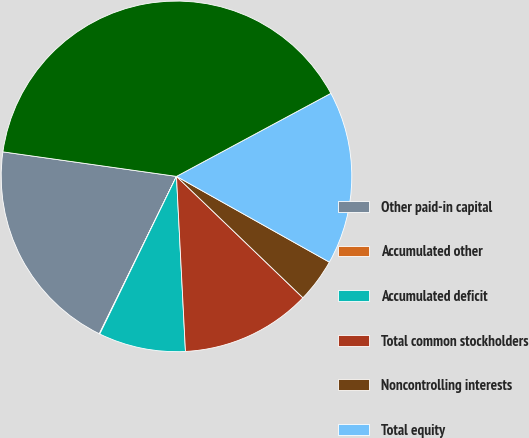Convert chart to OTSL. <chart><loc_0><loc_0><loc_500><loc_500><pie_chart><fcel>Other paid-in capital<fcel>Accumulated other<fcel>Accumulated deficit<fcel>Total common stockholders<fcel>Noncontrolling interests<fcel>Total equity<fcel>Total Liabilities and Equity<nl><fcel>19.98%<fcel>0.05%<fcel>8.02%<fcel>12.01%<fcel>4.04%<fcel>15.99%<fcel>39.91%<nl></chart> 